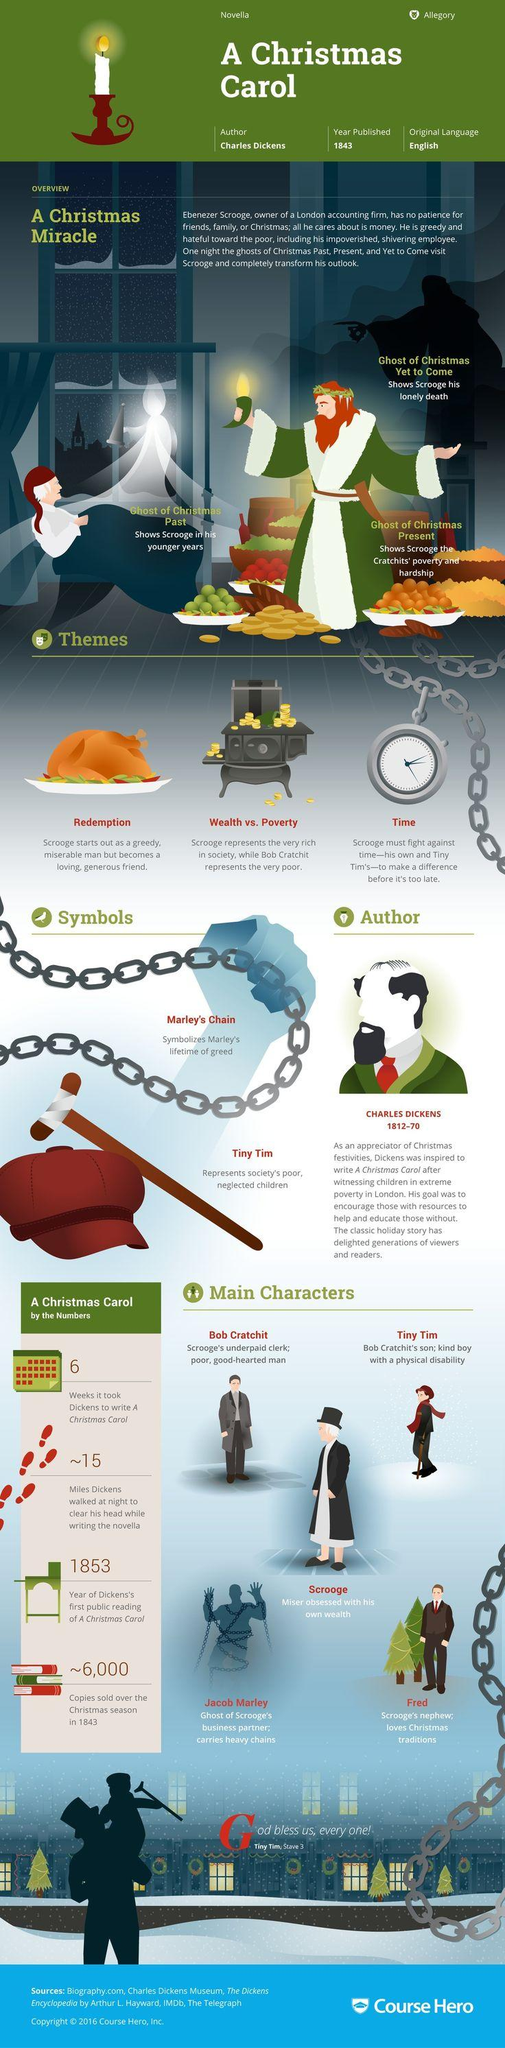Identify some key points in this picture. The main character in the novel "A Christmas Carol" is a miser who is obsessed with his own wealth and greed, playing a significant role in the story. In "A Christmas Carol," two metaphors are used: Marley's Chain and Tiny Tim. It is revealed in the novel that Jacob Marley is the character who is wearing big chains. In the novel "A Christmas Carol," the second metaphor used is "Tiny Tim as a crutch. Charles Dickens was inspired to write a novel about Christmas after witnessing the extreme poverty of children living in London. 